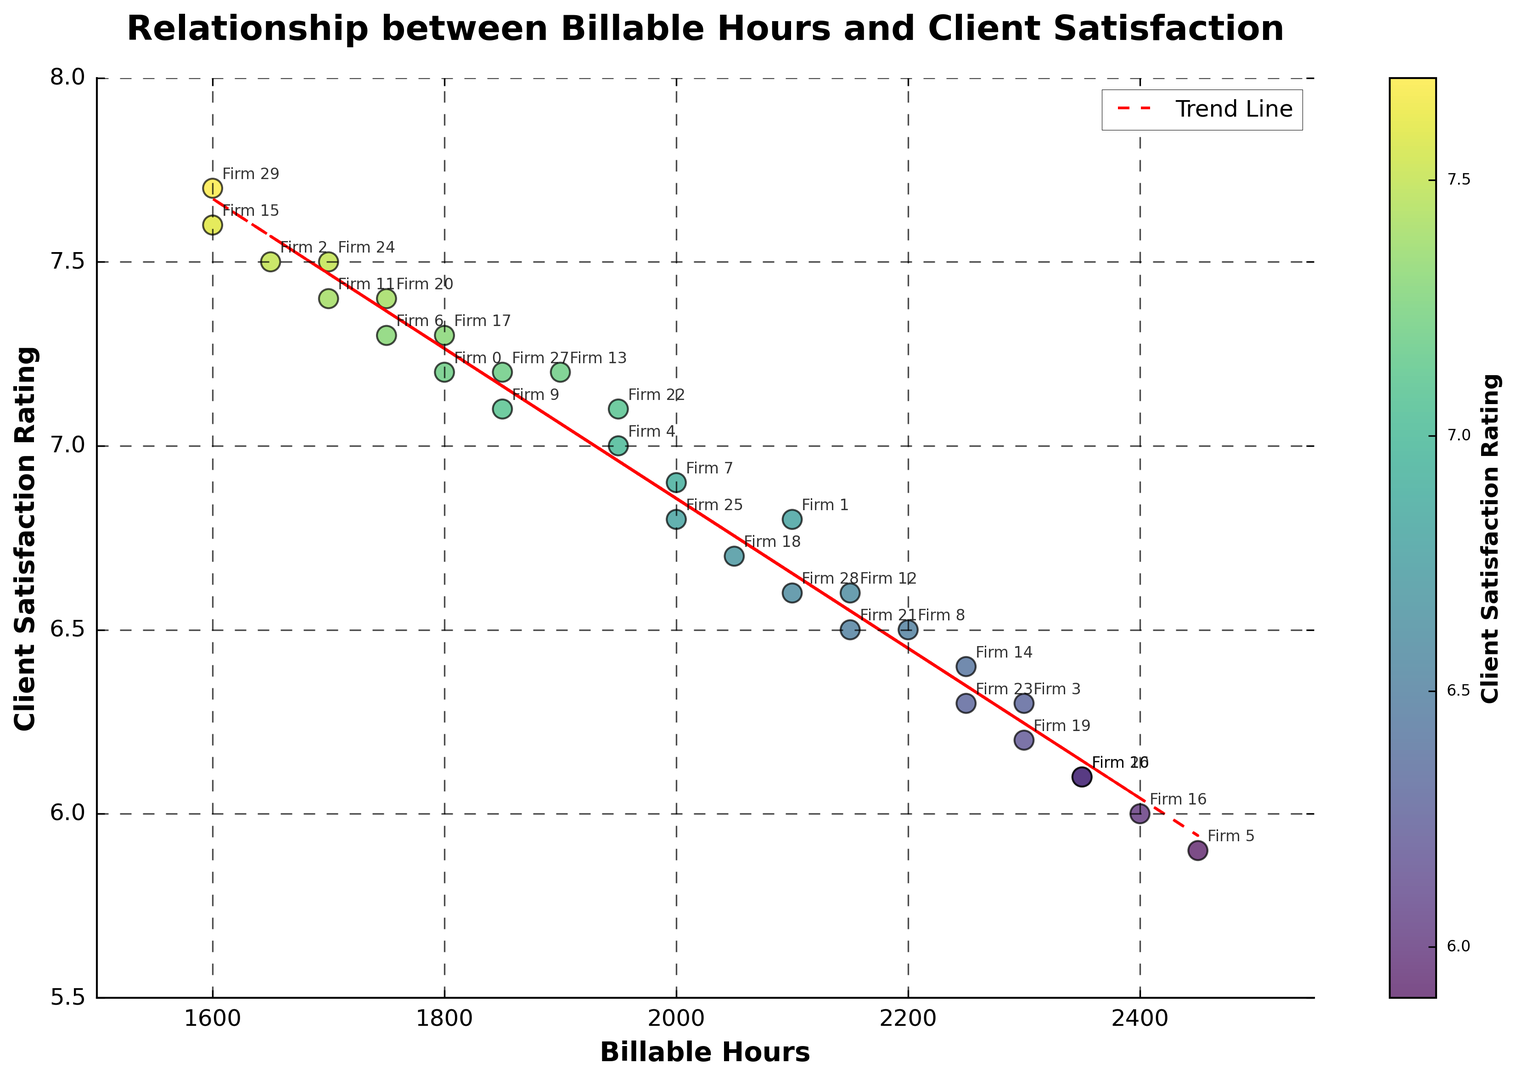What's the average client satisfaction rating? Sum the client satisfaction ratings from the figure and divide by the number of firms. Sum = 209.6, number of firms = 30. Average = 209.6 / 30
Answer: 6.9867 How does the trend line describe the relationship between billable hours and client satisfaction? The trend line is a visual representation of the overall trend in the scatter plot, showing a downward slope. This indicates a negative correlation, meaning as billable hours increase, client satisfaction tends to decrease.
Answer: Negative correlation Which data point has the highest client satisfaction rating, and what are its billable hours? Find the highest point on the y-axis (client satisfaction rating). The point at (1600, 7.7) represents the highest rating.
Answer: 1600 billable hours, 7.7 rating Are there any firms with the same client satisfaction rating but different billable hours? Look for points that share the same y-axis value but have different x-axis values. For instance, several firms have a satisfaction rating of 7.2 but different billable hours (1800 and 1900).
Answer: Yes What is the client satisfaction rating for the firm with 2300 billable hours? Locate the x-axis value "2300" and check the corresponding y-axis value(s). Two firms have 2300 billable hours with ratings of 6.3 and 6.2.
Answer: 6.3 and 6.2 Which firm has the least billable hours, and what is its client satisfaction rating? Find the lowest x-axis value for billable hours (1600) and check the corresponding y-axis value. The satisfaction rating is 7.6.
Answer: 1600 billable hours, 7.6 rating Which firms fall on the trend line? Identify points that lie along the red dashed line. These points approximately represent the average trend. Firms near the trend line are varied but include examples like (2000, 6.7) and (2100, 6.6).
Answer: Varied, examples include 2000, 6.7 Is there a significant difference in client satisfaction ratings for firms with billable hours greater than 2200 compared to those with billable hours less than 1800? Compare the cluster of points right of the 2200 mark with those left of 1800 on the x-axis. Firms with more than 2200 hours have ratings around 5.9 to 6.4, while firms with fewer than 1800 hours have ratings around 7.2 to 7.7, indicating higher satisfaction.
Answer: Yes, higher satisfaction with fewer billable hours What is the range of client satisfaction ratings in the plot? Identify the highest and lowest values on the y-axis (7.7 and 5.9), then subtract the lowest from the highest to determine the range. Range = 7.7 - 5.9 = 1.8.
Answer: 1.8 